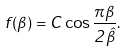<formula> <loc_0><loc_0><loc_500><loc_500>f ( \beta ) = C \cos \frac { \pi \beta } { 2 \hat { \beta } } .</formula> 